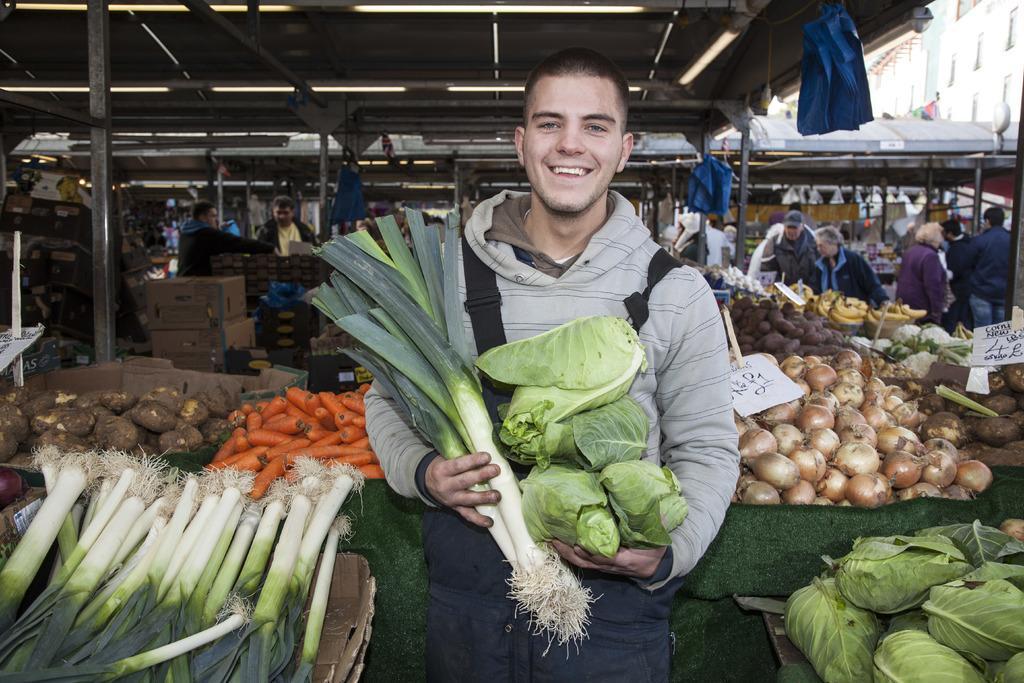How would you summarize this image in a sentence or two? In the picture I can see people are standing among them the man in the front of the image is holding vegetables in hands. In the background I can see carrots, onions and some other vegetables. I can also see boxes and some other objects in the background. 